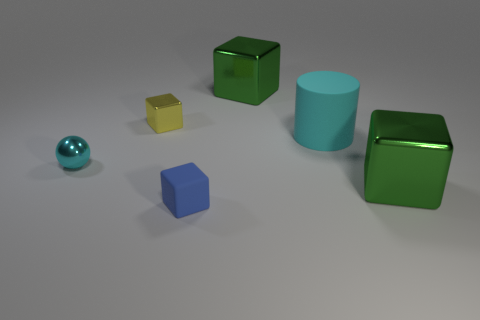Add 2 big brown rubber balls. How many objects exist? 8 Subtract all cubes. How many objects are left? 2 Add 6 yellow objects. How many yellow objects exist? 7 Subtract 0 red spheres. How many objects are left? 6 Subtract all cyan objects. Subtract all small rubber things. How many objects are left? 3 Add 2 big cubes. How many big cubes are left? 4 